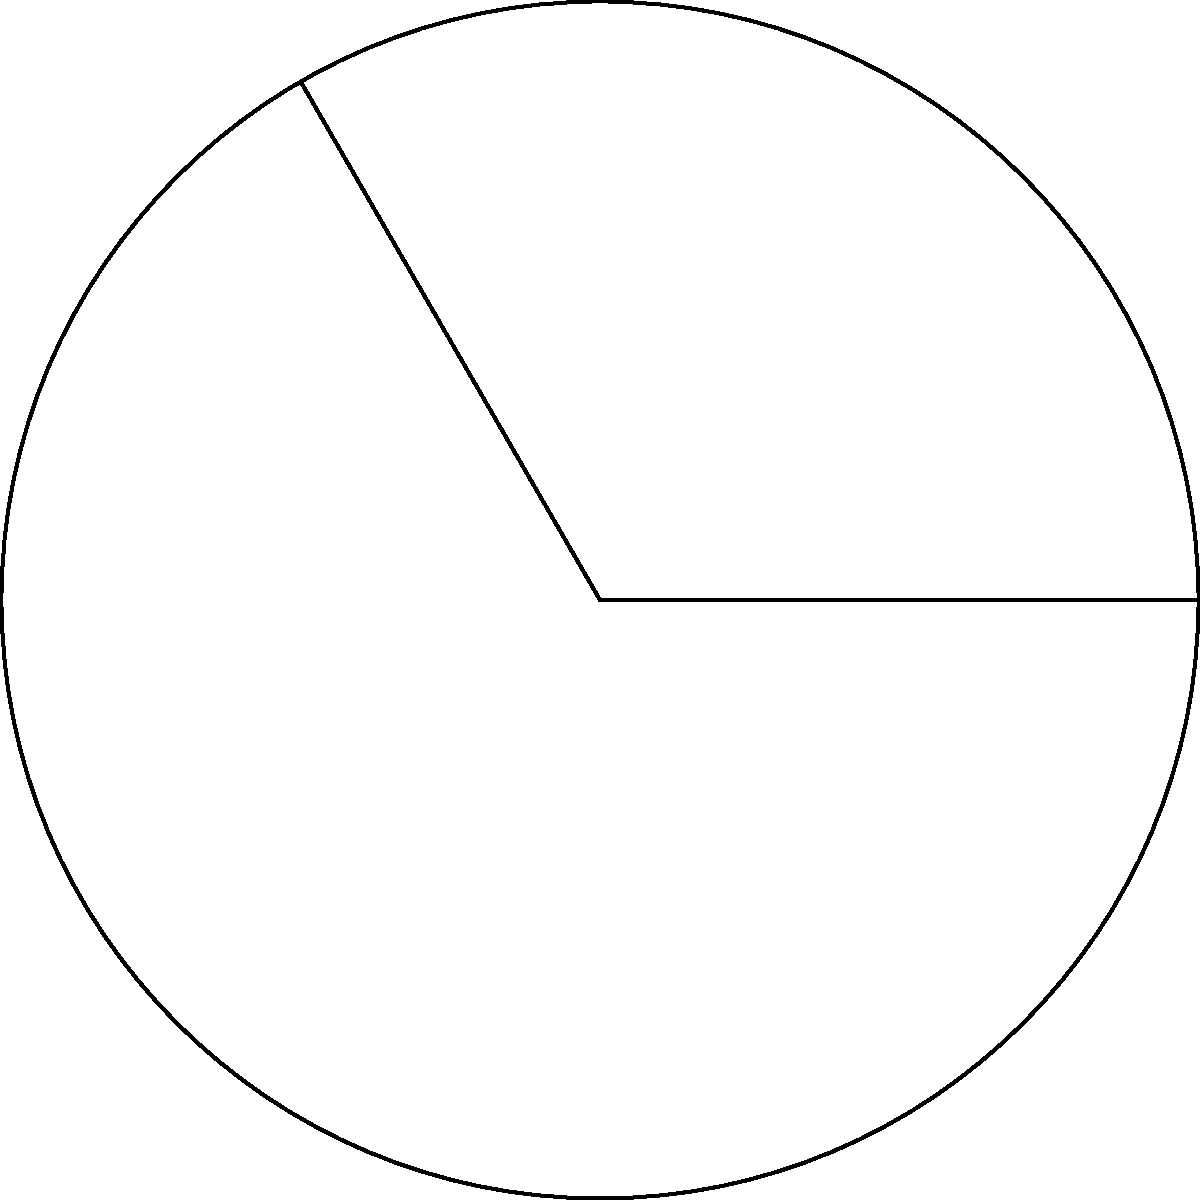In an embedded system's circular sensor array, you need to calculate the active area. Given a circular sector with a central angle of 120° and a radius of 5 cm, determine the area of the sector. Round your answer to two decimal places. To calculate the area of a circular sector, we can follow these steps:

1. Recall the formula for the area of a circular sector:
   $$A = \frac{1}{2} r^2 \theta$$
   where $A$ is the area, $r$ is the radius, and $\theta$ is the central angle in radians.

2. Convert the central angle from degrees to radians:
   $$\theta = 120° \times \frac{\pi}{180°} = \frac{2\pi}{3} \text{ radians}$$

3. Substitute the values into the formula:
   $$A = \frac{1}{2} \times 5^2 \times \frac{2\pi}{3}$$

4. Simplify:
   $$A = \frac{25\pi}{3} \text{ cm}^2$$

5. Calculate the result:
   $$A \approx 26.18 \text{ cm}^2$$

6. Round to two decimal places:
   $$A \approx 26.18 \text{ cm}^2$$
Answer: 26.18 cm² 